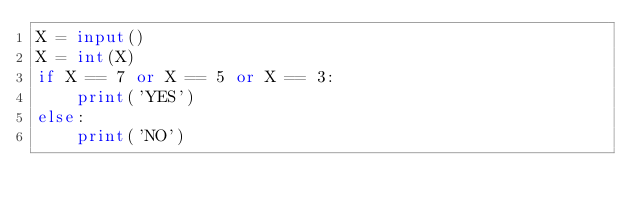Convert code to text. <code><loc_0><loc_0><loc_500><loc_500><_Python_>X = input()
X = int(X)
if X == 7 or X == 5 or X == 3:
    print('YES')
else:
    print('NO')</code> 